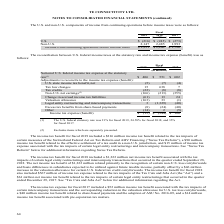According to Te Connectivity's financial document, What was the statutory rate used in fiscal 2019 when calculating the Notional U.S. federal income tax expense? According to the financial document, 21%. The relevant text states: "(1) The U.S. federal statutory rate was 21% for fiscal 2019, 24.58% for fiscal 2018, and 35% for fiscal 2017...." Also, What do the Non-U.S. net earnings exclude? items which are separately presented.. The document states: "(2) Excludes items which are separately presented...." Also, In which years was the income tax expense (benefit) calculated for? The document contains multiple relevant values: 2019, 2018, 2017. From the document: "2019 2018 2017 2019 2018 2017 2019 2018 2017..." Additionally, In which year was the Notional U.S. federal income tax expense at the statutory rate the largest? According to the financial document, 2017. The relevant text states: "2019 2018 2017..." Also, can you calculate: What was the change in Notional U.S. federal income tax expense at the statutory rate in 2019 from 2018? Based on the calculation: 406-551, the result is -145 (in millions). This is based on the information: "ome tax expense at the statutory rate (1) $ 406 $ 551 $ 602 al income tax expense at the statutory rate (1) $ 406 $ 551 $ 602..." The key data points involved are: 406, 551. Also, can you calculate: What was the percentage change in Notional U.S. federal income tax expense at the statutory rate in 2019 from 2018? To answer this question, I need to perform calculations using the financial data. The calculation is: (406-551)/551, which equals -26.32 (percentage). This is based on the information: "ome tax expense at the statutory rate (1) $ 406 $ 551 $ 602 al income tax expense at the statutory rate (1) $ 406 $ 551 $ 602..." The key data points involved are: 406, 551. 